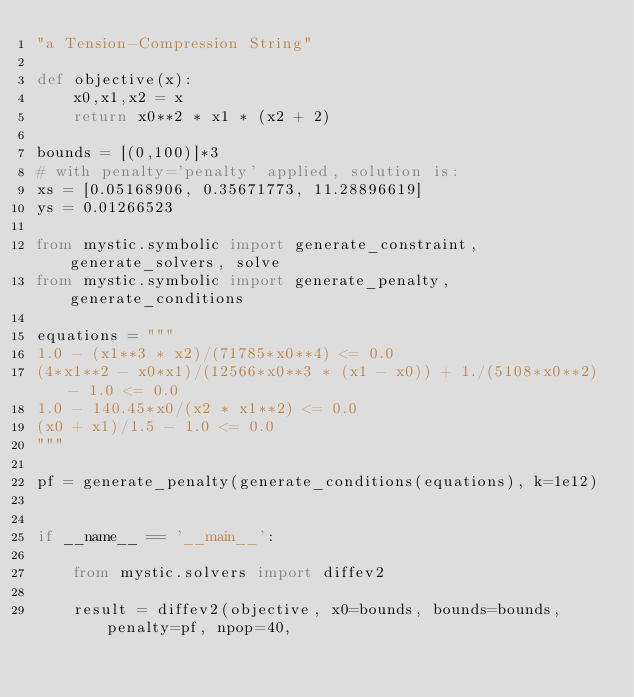Convert code to text. <code><loc_0><loc_0><loc_500><loc_500><_Python_>"a Tension-Compression String"

def objective(x):
    x0,x1,x2 = x
    return x0**2 * x1 * (x2 + 2)

bounds = [(0,100)]*3
# with penalty='penalty' applied, solution is:
xs = [0.05168906, 0.35671773, 11.28896619]
ys = 0.01266523

from mystic.symbolic import generate_constraint, generate_solvers, solve
from mystic.symbolic import generate_penalty, generate_conditions

equations = """
1.0 - (x1**3 * x2)/(71785*x0**4) <= 0.0
(4*x1**2 - x0*x1)/(12566*x0**3 * (x1 - x0)) + 1./(5108*x0**2) - 1.0 <= 0.0
1.0 - 140.45*x0/(x2 * x1**2) <= 0.0
(x0 + x1)/1.5 - 1.0 <= 0.0
"""

pf = generate_penalty(generate_conditions(equations), k=1e12)


if __name__ == '__main__':

    from mystic.solvers import diffev2

    result = diffev2(objective, x0=bounds, bounds=bounds, penalty=pf, npop=40,</code> 